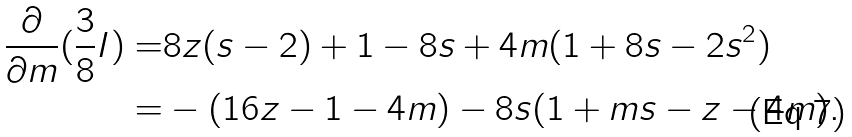Convert formula to latex. <formula><loc_0><loc_0><loc_500><loc_500>\frac { \partial } { \partial m } ( \frac { 3 } { 8 } I ) = & 8 z ( s - 2 ) + 1 - 8 s + 4 m ( 1 + 8 s - 2 s ^ { 2 } ) \\ = & - ( 1 6 z - 1 - 4 m ) - 8 s ( 1 + m s - z - 4 m ) .</formula> 